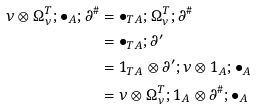<formula> <loc_0><loc_0><loc_500><loc_500>\nu \otimes \Omega _ { \nu } ^ { T } ; \bullet _ { A } ; \partial ^ { \# } & = \bullet _ { T A } ; \Omega _ { \nu } ^ { T } ; \partial ^ { \# } \\ & = \bullet _ { T A } ; \partial ^ { \prime } \\ & = 1 _ { T A } \otimes \partial ^ { \prime } ; \nu \otimes 1 _ { A } ; \bullet _ { A } \\ & = \nu \otimes \Omega _ { \nu } ^ { T } ; 1 _ { A } \otimes \partial ^ { \# } ; \bullet _ { A }</formula> 